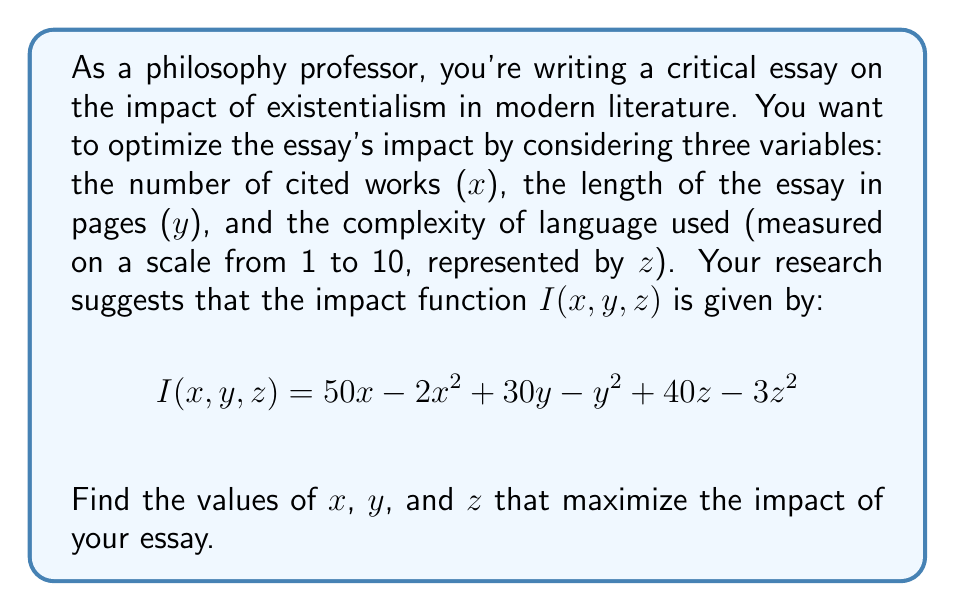Can you answer this question? To find the maximum impact, we need to find the critical points of the function $I(x,y,z)$ and evaluate them. We'll use partial derivatives and set them equal to zero:

1) Find partial derivatives:
   $$\frac{\partial I}{\partial x} = 50 - 4x$$
   $$\frac{\partial I}{\partial y} = 30 - 2y$$
   $$\frac{\partial I}{\partial z} = 40 - 6z$$

2) Set each partial derivative to zero and solve:
   $$50 - 4x = 0 \implies x = 12.5$$
   $$30 - 2y = 0 \implies y = 15$$
   $$40 - 6z = 0 \implies z = \frac{20}{3} \approx 6.67$$

3) To confirm this is a maximum, we can check the second partial derivatives:
   $$\frac{\partial^2 I}{\partial x^2} = -4$$
   $$\frac{\partial^2 I}{\partial y^2} = -2$$
   $$\frac{\partial^2 I}{\partial z^2} = -6$$

   All second partial derivatives are negative, confirming a local maximum.

4) The optimal values are:
   $x = 12.5$ cited works
   $y = 15$ pages
   $z = \frac{20}{3} \approx 6.67$ on the complexity scale

5) Round to practical values:
   $x = 13$ cited works (round up for academic rigor)
   $y = 15$ pages
   $z = 7$ on the complexity scale (round up for philosophical depth)
Answer: $x = 13$, $y = 15$, $z = 7$ 